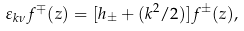Convert formula to latex. <formula><loc_0><loc_0><loc_500><loc_500>\varepsilon _ { k \nu } f ^ { \mp } ( z ) = [ h _ { \pm } + ( k ^ { 2 } / 2 ) ] f ^ { \pm } ( z ) , \\</formula> 